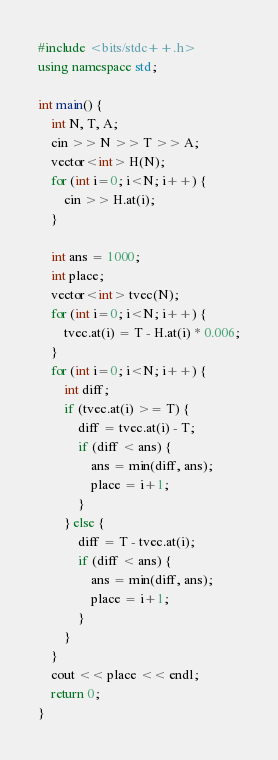<code> <loc_0><loc_0><loc_500><loc_500><_C++_>#include <bits/stdc++.h>
using namespace std;

int main() {
    int N, T, A;
    cin >> N >> T >> A;
    vector<int> H(N);
    for (int i=0; i<N; i++) {
        cin >> H.at(i);
    }

    int ans = 1000;
    int place;
    vector<int> tvec(N);
    for (int i=0; i<N; i++) {
        tvec.at(i) = T - H.at(i) * 0.006;
    }
    for (int i=0; i<N; i++) {
        int diff;
        if (tvec.at(i) >= T) {
            diff = tvec.at(i) - T;
            if (diff < ans) {
                ans = min(diff, ans);
                place = i+1;
            }
        } else {
            diff = T - tvec.at(i);
            if (diff < ans) {
                ans = min(diff, ans);
                place = i+1;
            }
        }
    }
    cout << place << endl;
    return 0;
}
</code> 